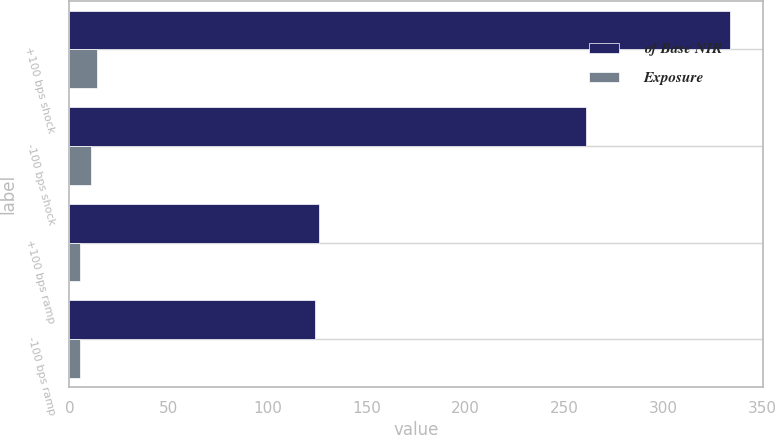Convert chart. <chart><loc_0><loc_0><loc_500><loc_500><stacked_bar_chart><ecel><fcel>+100 bps shock<fcel>-100 bps shock<fcel>+100 bps ramp<fcel>-100 bps ramp<nl><fcel>of Base NIR<fcel>334<fcel>261<fcel>126<fcel>124<nl><fcel>Exposure<fcel>14<fcel>10.9<fcel>5.3<fcel>5.2<nl></chart> 